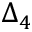<formula> <loc_0><loc_0><loc_500><loc_500>\Delta _ { 4 }</formula> 